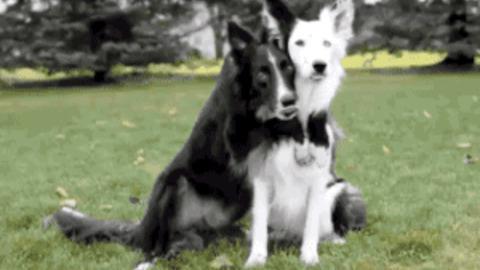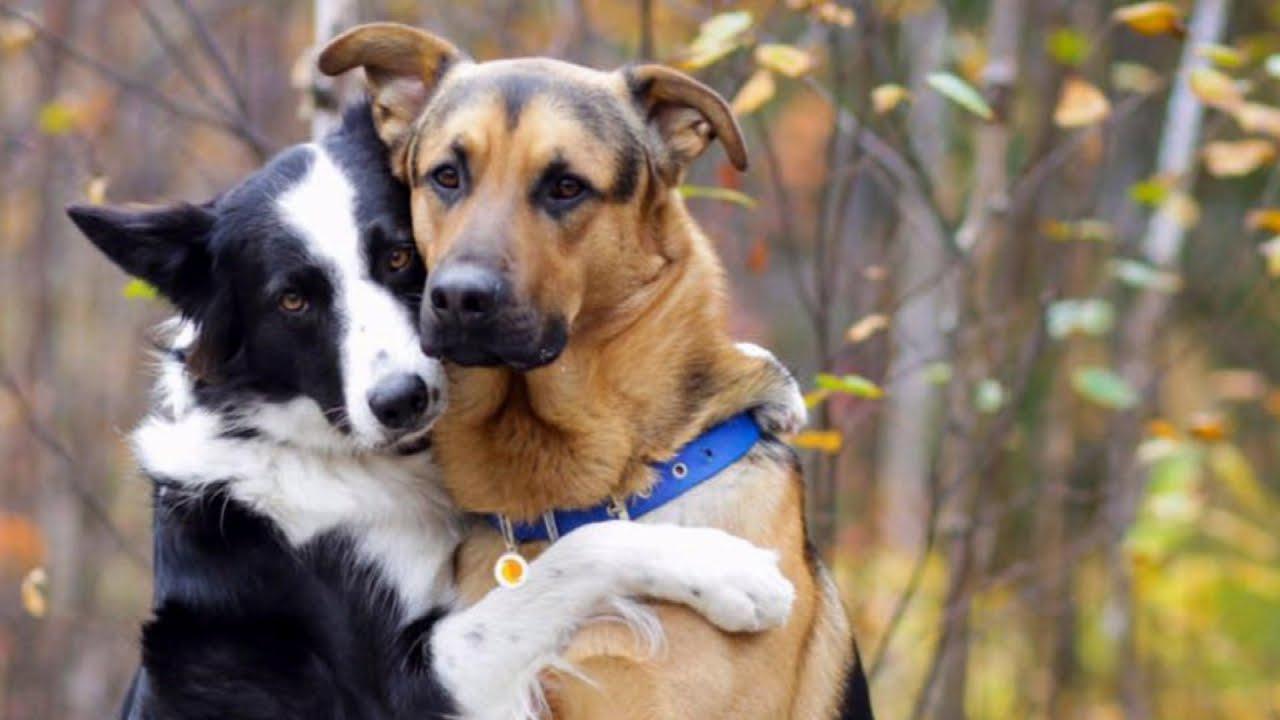The first image is the image on the left, the second image is the image on the right. Assess this claim about the two images: "Both images show two dogs outside.". Correct or not? Answer yes or no. Yes. 